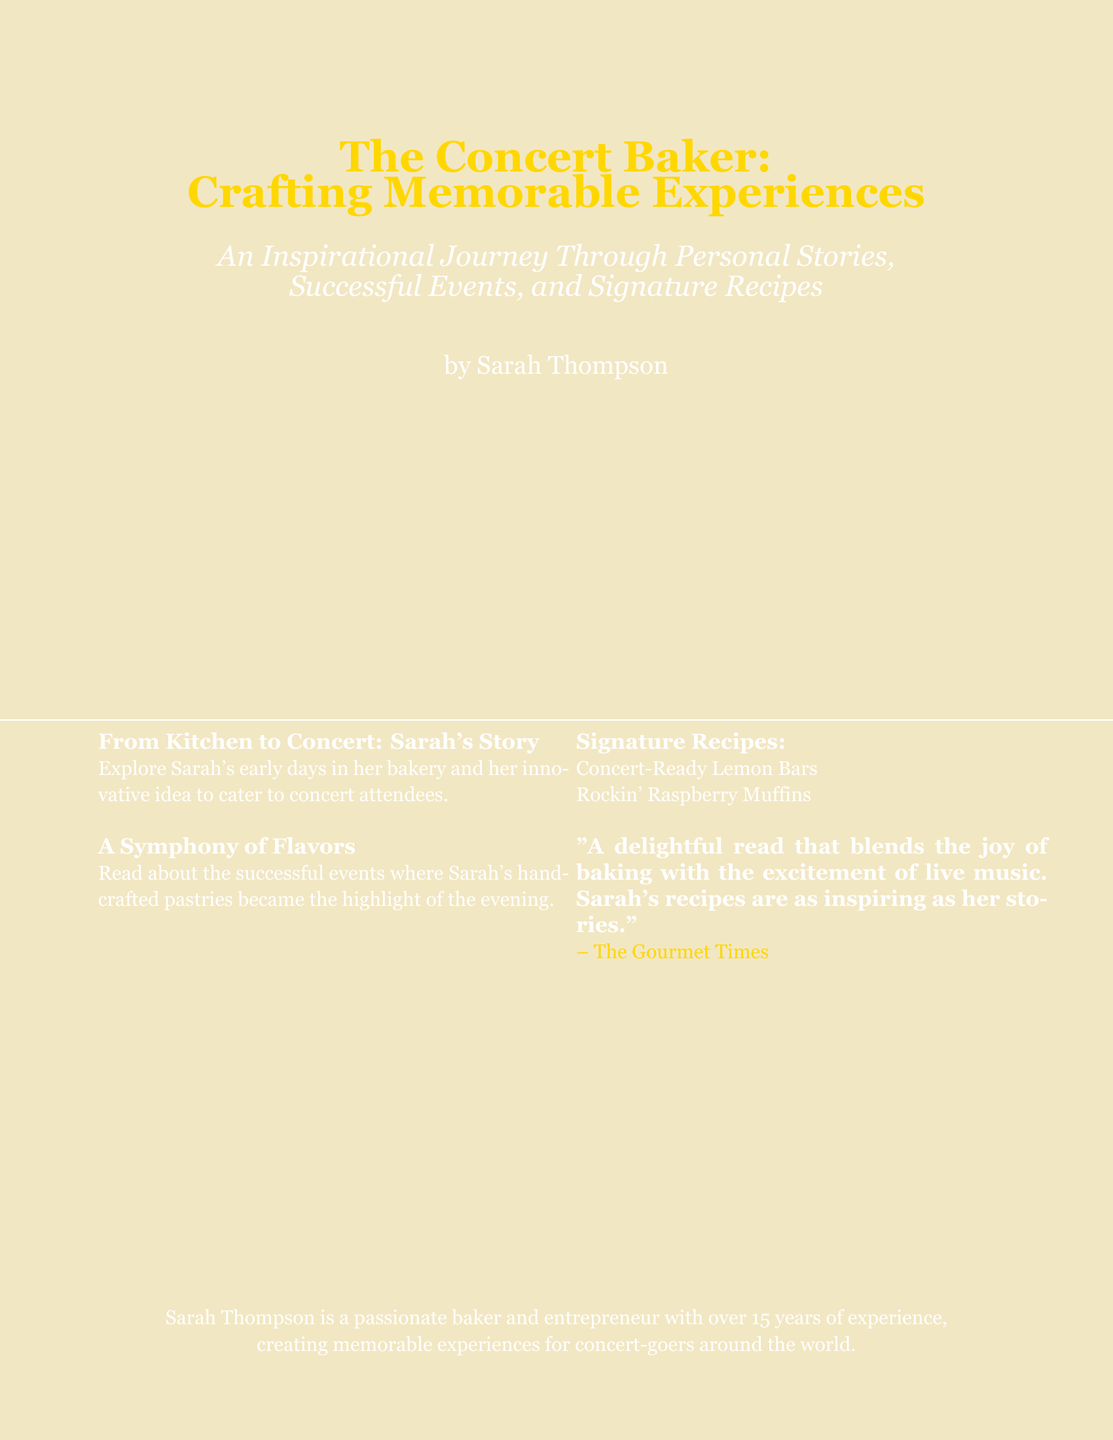What is the title of the book? The title of the book is found prominently at the top of the document, stating the theme and purpose.
Answer: The Concert Baker: Crafting Memorable Experiences Who is the author of the book? The name of the author is mentioned at the bottom section of the cover.
Answer: Sarah Thompson What type of recipes does the book include? The document lists specific types of recipes highlighting the culinary aspect of the content.
Answer: Concert-Ready Lemon Bars, Rockin' Raspberry Muffins What is the main theme of the book? The theme connects personal stories and experiences with the art of baking for concert attendees.
Answer: Crafting Memorable Experiences How many years of experience does Sarah have? The book includes information about the author's professional background and experience in the pastry field.
Answer: Over 15 years 